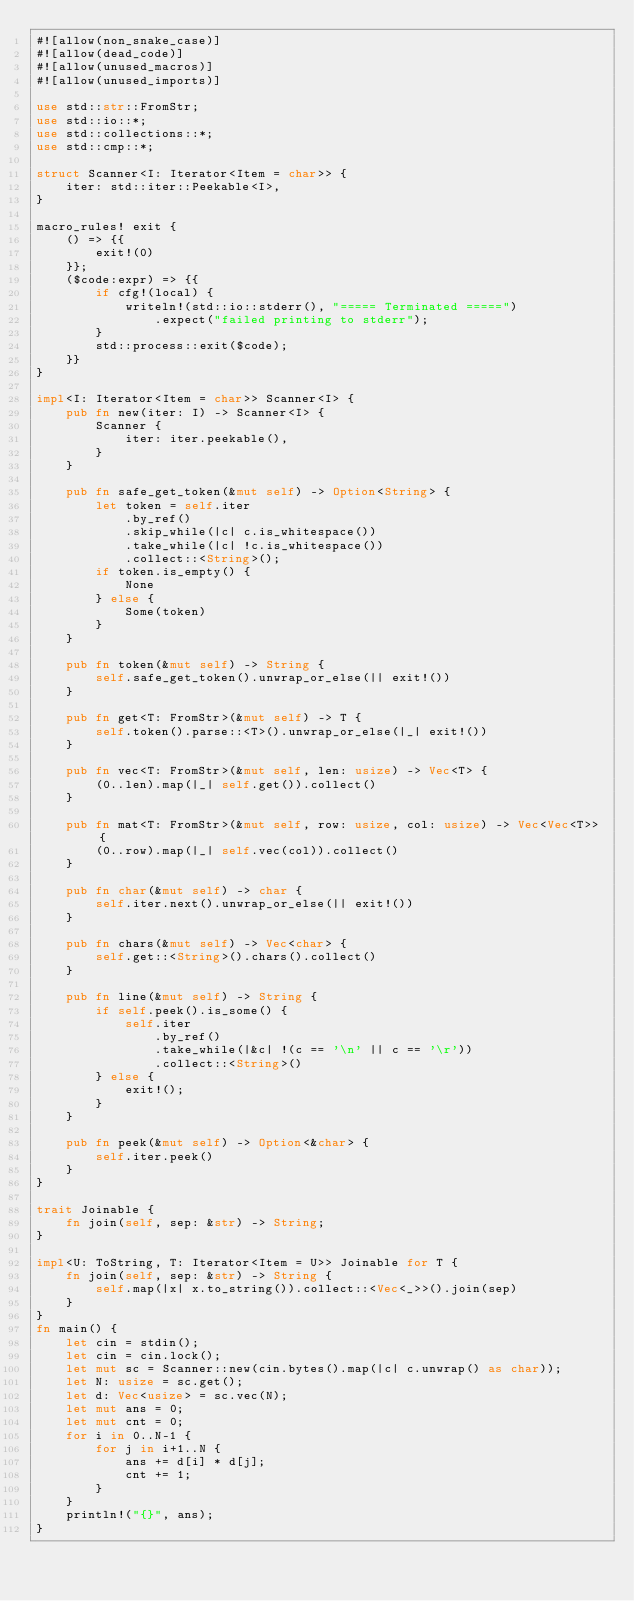<code> <loc_0><loc_0><loc_500><loc_500><_Rust_>#![allow(non_snake_case)]
#![allow(dead_code)]
#![allow(unused_macros)]
#![allow(unused_imports)]

use std::str::FromStr;
use std::io::*;
use std::collections::*;
use std::cmp::*;

struct Scanner<I: Iterator<Item = char>> {
    iter: std::iter::Peekable<I>,
}

macro_rules! exit {
    () => {{
        exit!(0)
    }};
    ($code:expr) => {{
        if cfg!(local) {
            writeln!(std::io::stderr(), "===== Terminated =====")
                .expect("failed printing to stderr");
        }
        std::process::exit($code);
    }}
}

impl<I: Iterator<Item = char>> Scanner<I> {
    pub fn new(iter: I) -> Scanner<I> {
        Scanner {
            iter: iter.peekable(),
        }
    }

    pub fn safe_get_token(&mut self) -> Option<String> {
        let token = self.iter
            .by_ref()
            .skip_while(|c| c.is_whitespace())
            .take_while(|c| !c.is_whitespace())
            .collect::<String>();
        if token.is_empty() {
            None
        } else {
            Some(token)
        }
    }

    pub fn token(&mut self) -> String {
        self.safe_get_token().unwrap_or_else(|| exit!())
    }

    pub fn get<T: FromStr>(&mut self) -> T {
        self.token().parse::<T>().unwrap_or_else(|_| exit!())
    }

    pub fn vec<T: FromStr>(&mut self, len: usize) -> Vec<T> {
        (0..len).map(|_| self.get()).collect()
    }

    pub fn mat<T: FromStr>(&mut self, row: usize, col: usize) -> Vec<Vec<T>> {
        (0..row).map(|_| self.vec(col)).collect()
    }

    pub fn char(&mut self) -> char {
        self.iter.next().unwrap_or_else(|| exit!())
    }

    pub fn chars(&mut self) -> Vec<char> {
        self.get::<String>().chars().collect()
    }

    pub fn line(&mut self) -> String {
        if self.peek().is_some() {
            self.iter
                .by_ref()
                .take_while(|&c| !(c == '\n' || c == '\r'))
                .collect::<String>()
        } else {
            exit!();
        }
    }

    pub fn peek(&mut self) -> Option<&char> {
        self.iter.peek()
    }
}

trait Joinable {
    fn join(self, sep: &str) -> String;
}

impl<U: ToString, T: Iterator<Item = U>> Joinable for T {
    fn join(self, sep: &str) -> String {
        self.map(|x| x.to_string()).collect::<Vec<_>>().join(sep)
    }
}
fn main() {
    let cin = stdin();
    let cin = cin.lock();
    let mut sc = Scanner::new(cin.bytes().map(|c| c.unwrap() as char));
    let N: usize = sc.get();
    let d: Vec<usize> = sc.vec(N);
    let mut ans = 0;
    let mut cnt = 0;
    for i in 0..N-1 {
        for j in i+1..N {
            ans += d[i] * d[j];
            cnt += 1;
        }
    }
    println!("{}", ans);
}
</code> 